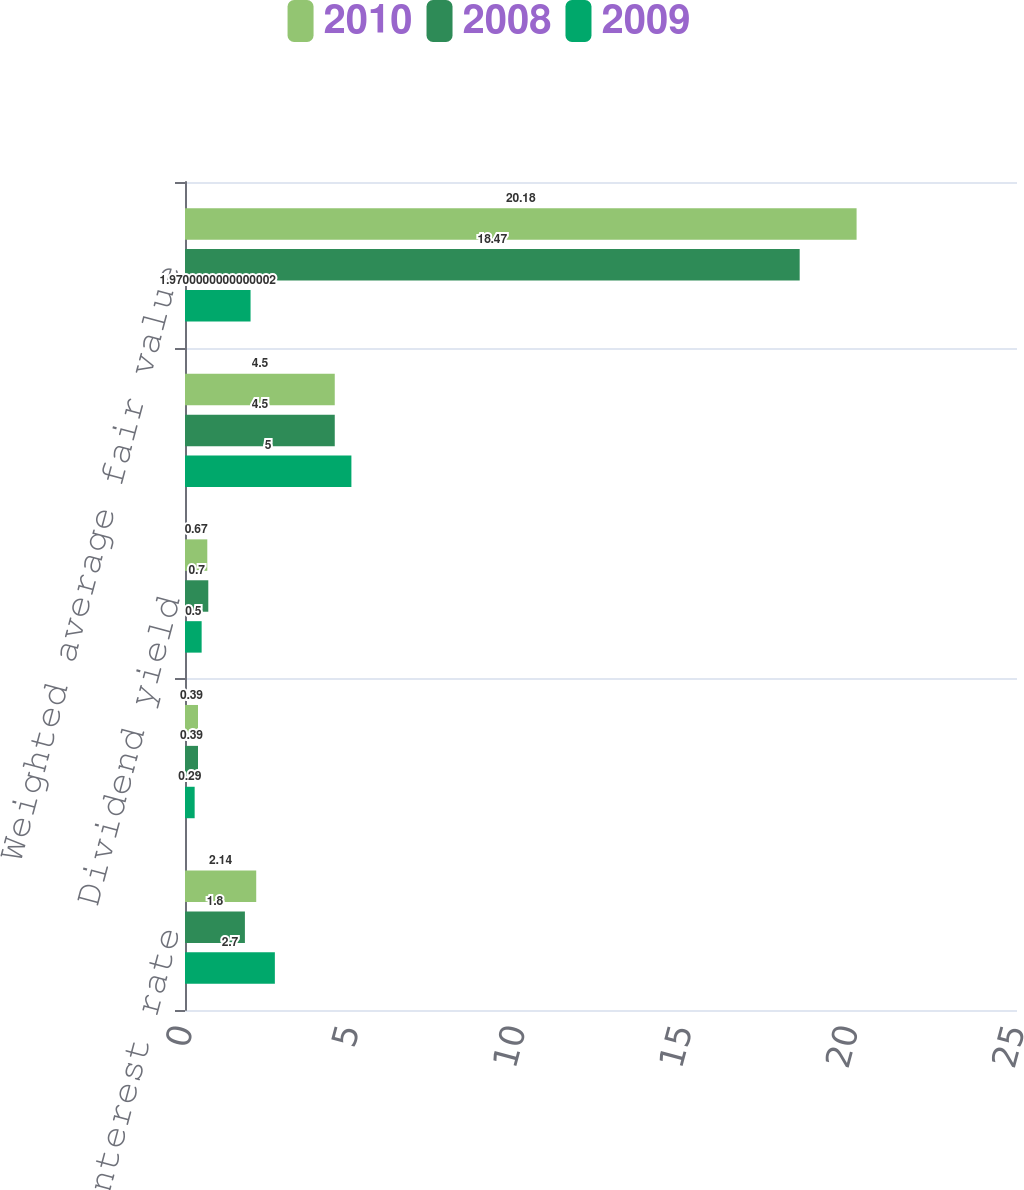<chart> <loc_0><loc_0><loc_500><loc_500><stacked_bar_chart><ecel><fcel>Risk free interest rate<fcel>Stock price volatility<fcel>Dividend yield<fcel>Expected term in years<fcel>Weighted average fair value<nl><fcel>2010<fcel>2.14<fcel>0.39<fcel>0.67<fcel>4.5<fcel>20.18<nl><fcel>2008<fcel>1.8<fcel>0.39<fcel>0.7<fcel>4.5<fcel>18.47<nl><fcel>2009<fcel>2.7<fcel>0.29<fcel>0.5<fcel>5<fcel>1.97<nl></chart> 